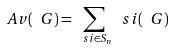Convert formula to latex. <formula><loc_0><loc_0><loc_500><loc_500>\ A v ( \ G ) = \sum _ { \ s i \in S _ { n } } \ s i ( \ G )</formula> 